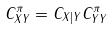<formula> <loc_0><loc_0><loc_500><loc_500>C _ { X Y } ^ { \pi } = C _ { X | Y } C _ { Y Y } ^ { \pi }</formula> 